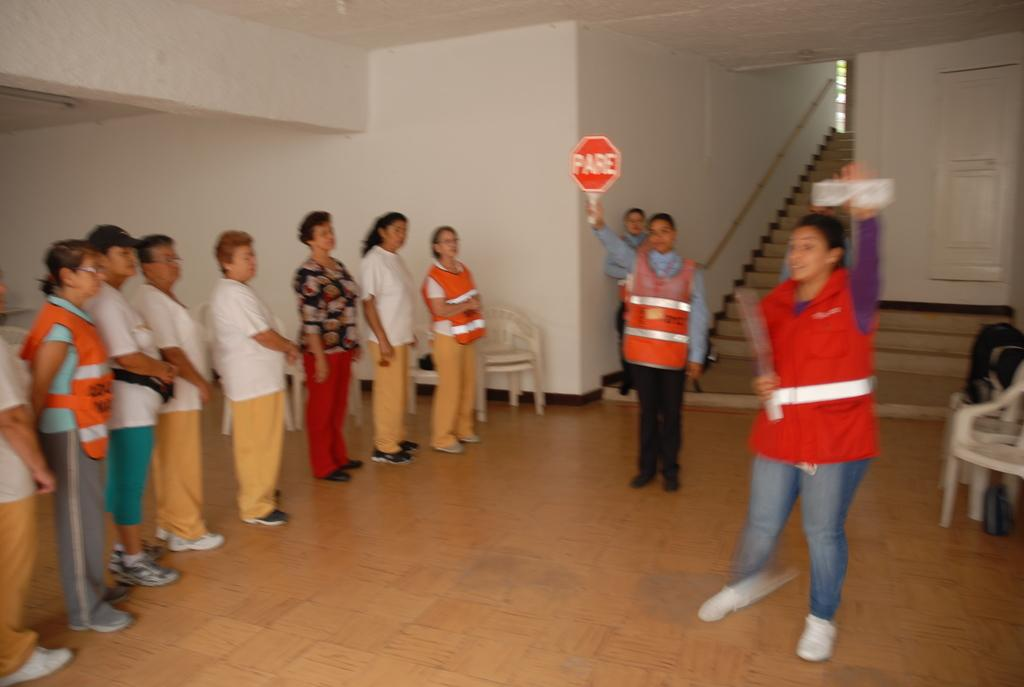Provide a one-sentence caption for the provided image. a woman in a reflective vest holding up a sign that says PARE. 